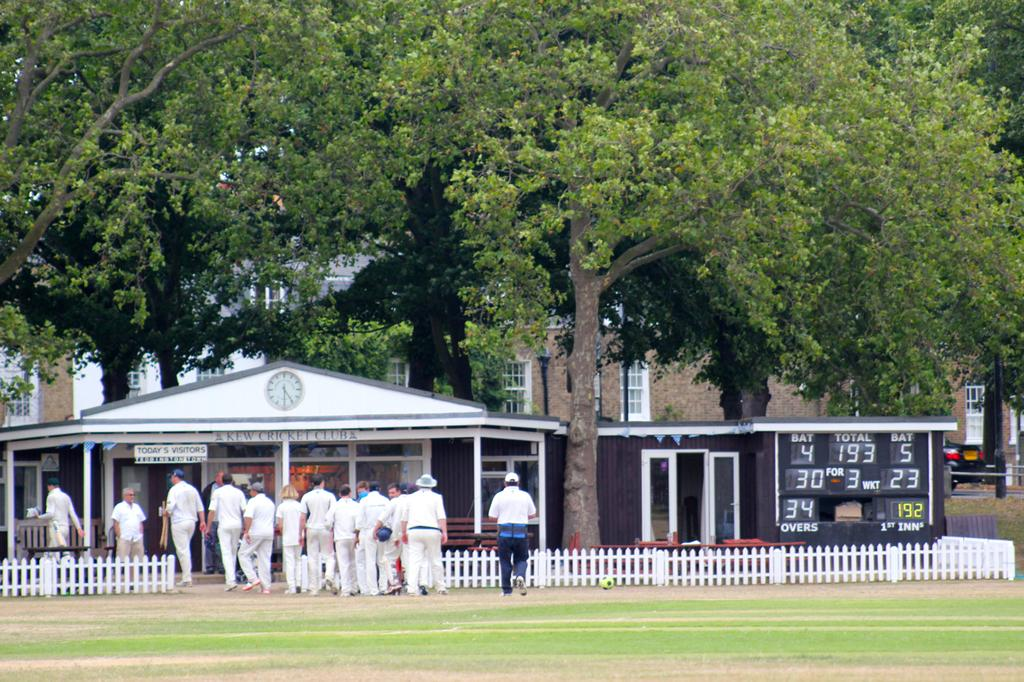What type of natural elements can be seen in the image? There are trees in the image. What type of man-made structures are present in the image? There are buildings, a shed, and fencing in the image. What architectural feature is visible in the image? There are windows in the image. What additional feature can be seen in the image related to sports or events? There is a scoreboard in the image. What is the activity of the people in the image? The people are walking in the image. What colors are the people wearing in the image? The people are wearing white and blue color dresses. Reasoning: Let's think step by breaking down the image into its main components. We start by identifying the natural elements, which are the trees. Then, we move on to the man-made structures, including buildings, a shed, and fencing. We also mention the architectural feature of windows. Next, we identify the sports or event-related feature, which is the scoreboard. Finally, we describe the people in the image, including their activity and the colors they are wearing. Absurd Question/Answer: How many tomatoes are hanging from the trees in the image? There are no tomatoes present in the image; it features trees, buildings, and people walking. What shape is the wrench that the person is holding in the image? There is no wrench present in the image. 